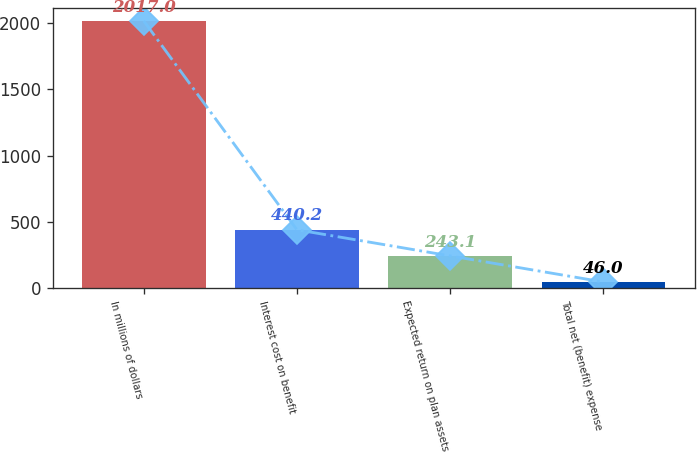Convert chart. <chart><loc_0><loc_0><loc_500><loc_500><bar_chart><fcel>In millions of dollars<fcel>Interest cost on benefit<fcel>Expected return on plan assets<fcel>Total net (benefit) expense<nl><fcel>2017<fcel>440.2<fcel>243.1<fcel>46<nl></chart> 